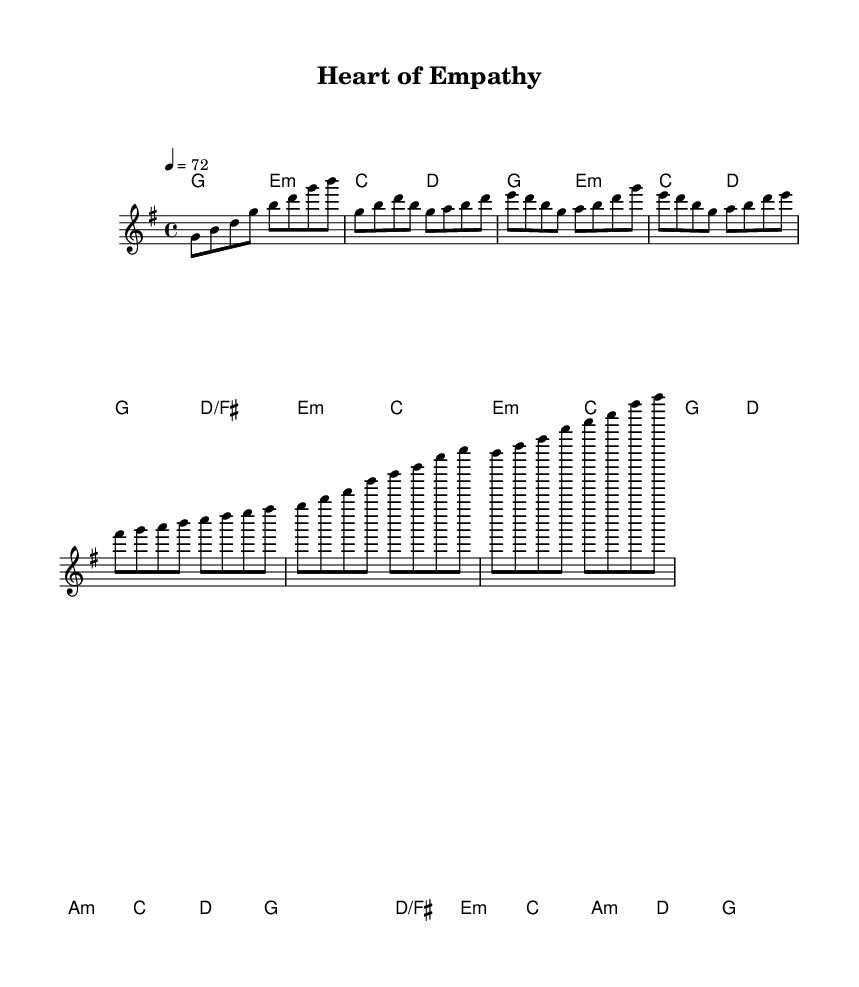What is the key signature of this music? The key signature is G major, which has one sharp (F sharp). This is identified at the beginning of the staff before the first note.
Answer: G major What is the time signature of this music? The time signature is 4/4, indicated at the beginning of the piece after the key signature. It shows that there are four beats in each measure, and the quarter note gets one beat.
Answer: 4/4 What is the tempo marking of this piece? The tempo marking indicates a speed of 72 beats per minute, shown above the staff. This denotes the tempo at which the music should be played.
Answer: 72 How many measures are in the chorus section? The chorus section contains four measures, as counted from the start of the chorus notation to its end. Each measure can be visually identified between the bar lines.
Answer: 4 What is the first note of the verse? The first note of the verse is G, which is found at the beginning of the verse notation. It is the first note encountered when reading the melody line.
Answer: G What type of harmony is used in the pre-chorus? The pre-chorus uses minor and major chords, which can be identified by the harmonic symbols above the melody staff. This indicates a variety of harmonic textures in that section.
Answer: Minor and major What theme does this ballad explore? The theme explored in this ballad is empathy and emotional connections, which can be inferred from the title "Heart of Empathy" and the context of K-Pop ballads.
Answer: Empathy and emotional connections 